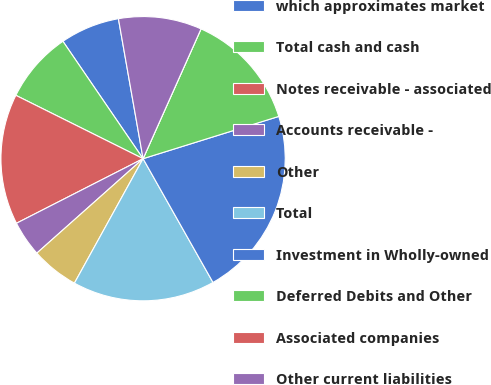Convert chart to OTSL. <chart><loc_0><loc_0><loc_500><loc_500><pie_chart><fcel>which approximates market<fcel>Total cash and cash<fcel>Notes receivable - associated<fcel>Accounts receivable -<fcel>Other<fcel>Total<fcel>Investment in Wholly-owned<fcel>Deferred Debits and Other<fcel>Associated companies<fcel>Other current liabilities<nl><fcel>6.76%<fcel>8.11%<fcel>14.86%<fcel>4.06%<fcel>5.41%<fcel>16.21%<fcel>21.62%<fcel>13.51%<fcel>0.0%<fcel>9.46%<nl></chart> 